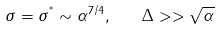Convert formula to latex. <formula><loc_0><loc_0><loc_500><loc_500>\sigma = \sigma ^ { ^ { * } } \sim \alpha ^ { 7 / 4 } , \quad \Delta > > \sqrt { \alpha }</formula> 